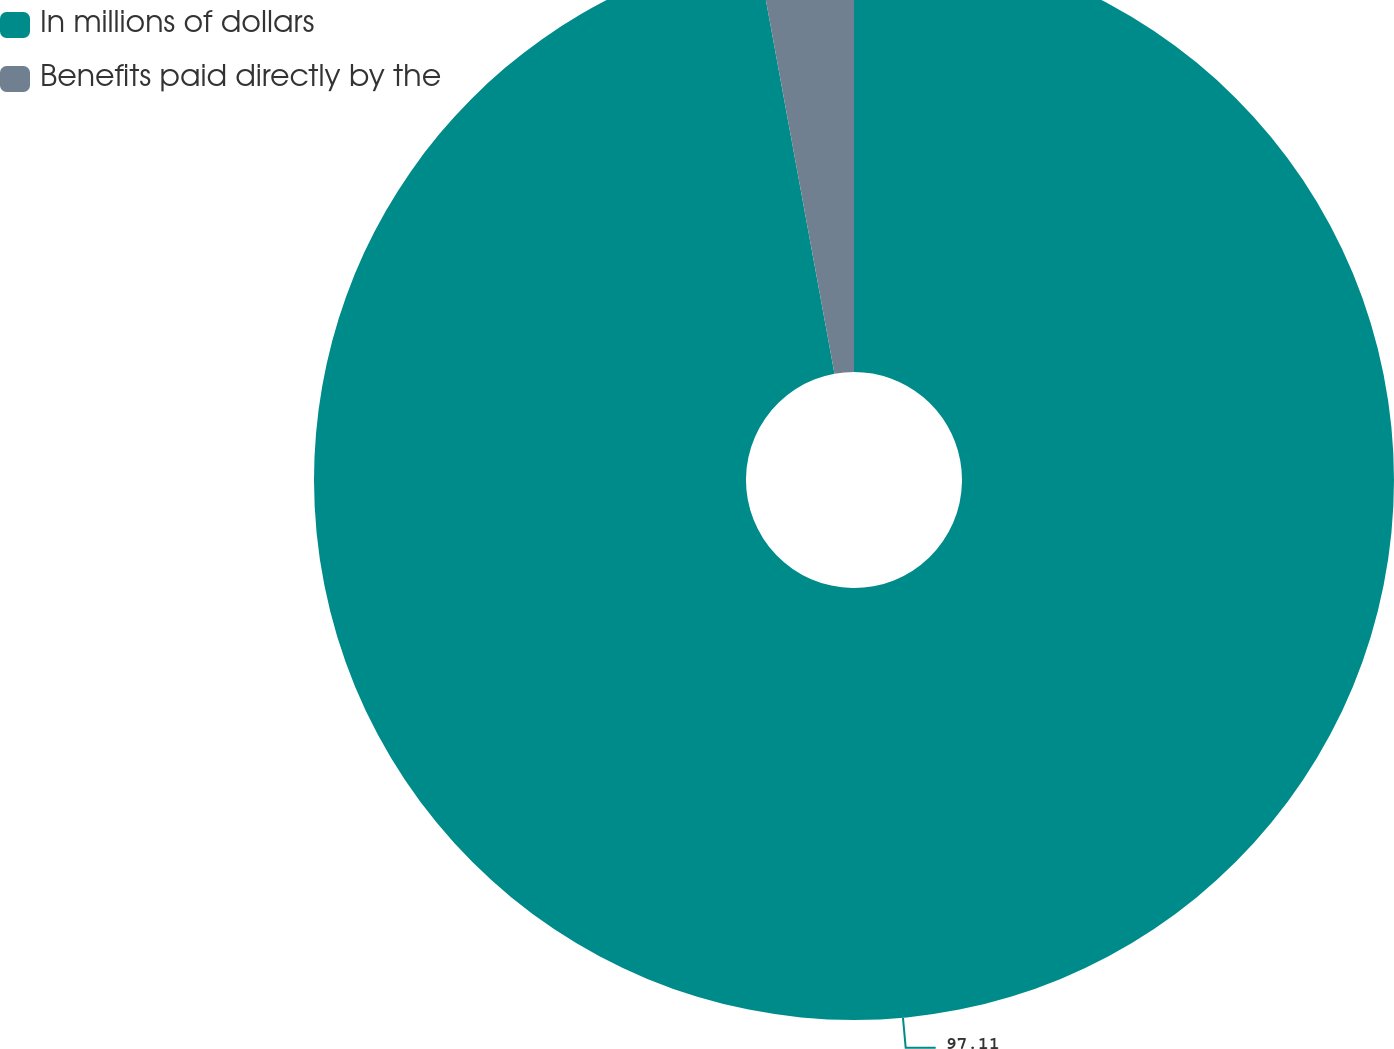Convert chart to OTSL. <chart><loc_0><loc_0><loc_500><loc_500><pie_chart><fcel>In millions of dollars<fcel>Benefits paid directly by the<nl><fcel>97.11%<fcel>2.89%<nl></chart> 